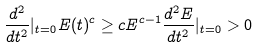Convert formula to latex. <formula><loc_0><loc_0><loc_500><loc_500>\frac { d ^ { 2 } } { d t ^ { 2 } } | _ { t = 0 } E ( t ) ^ { c } \geq c E ^ { c - 1 } \frac { d ^ { 2 } E } { d t ^ { 2 } } | _ { t = 0 } > 0</formula> 